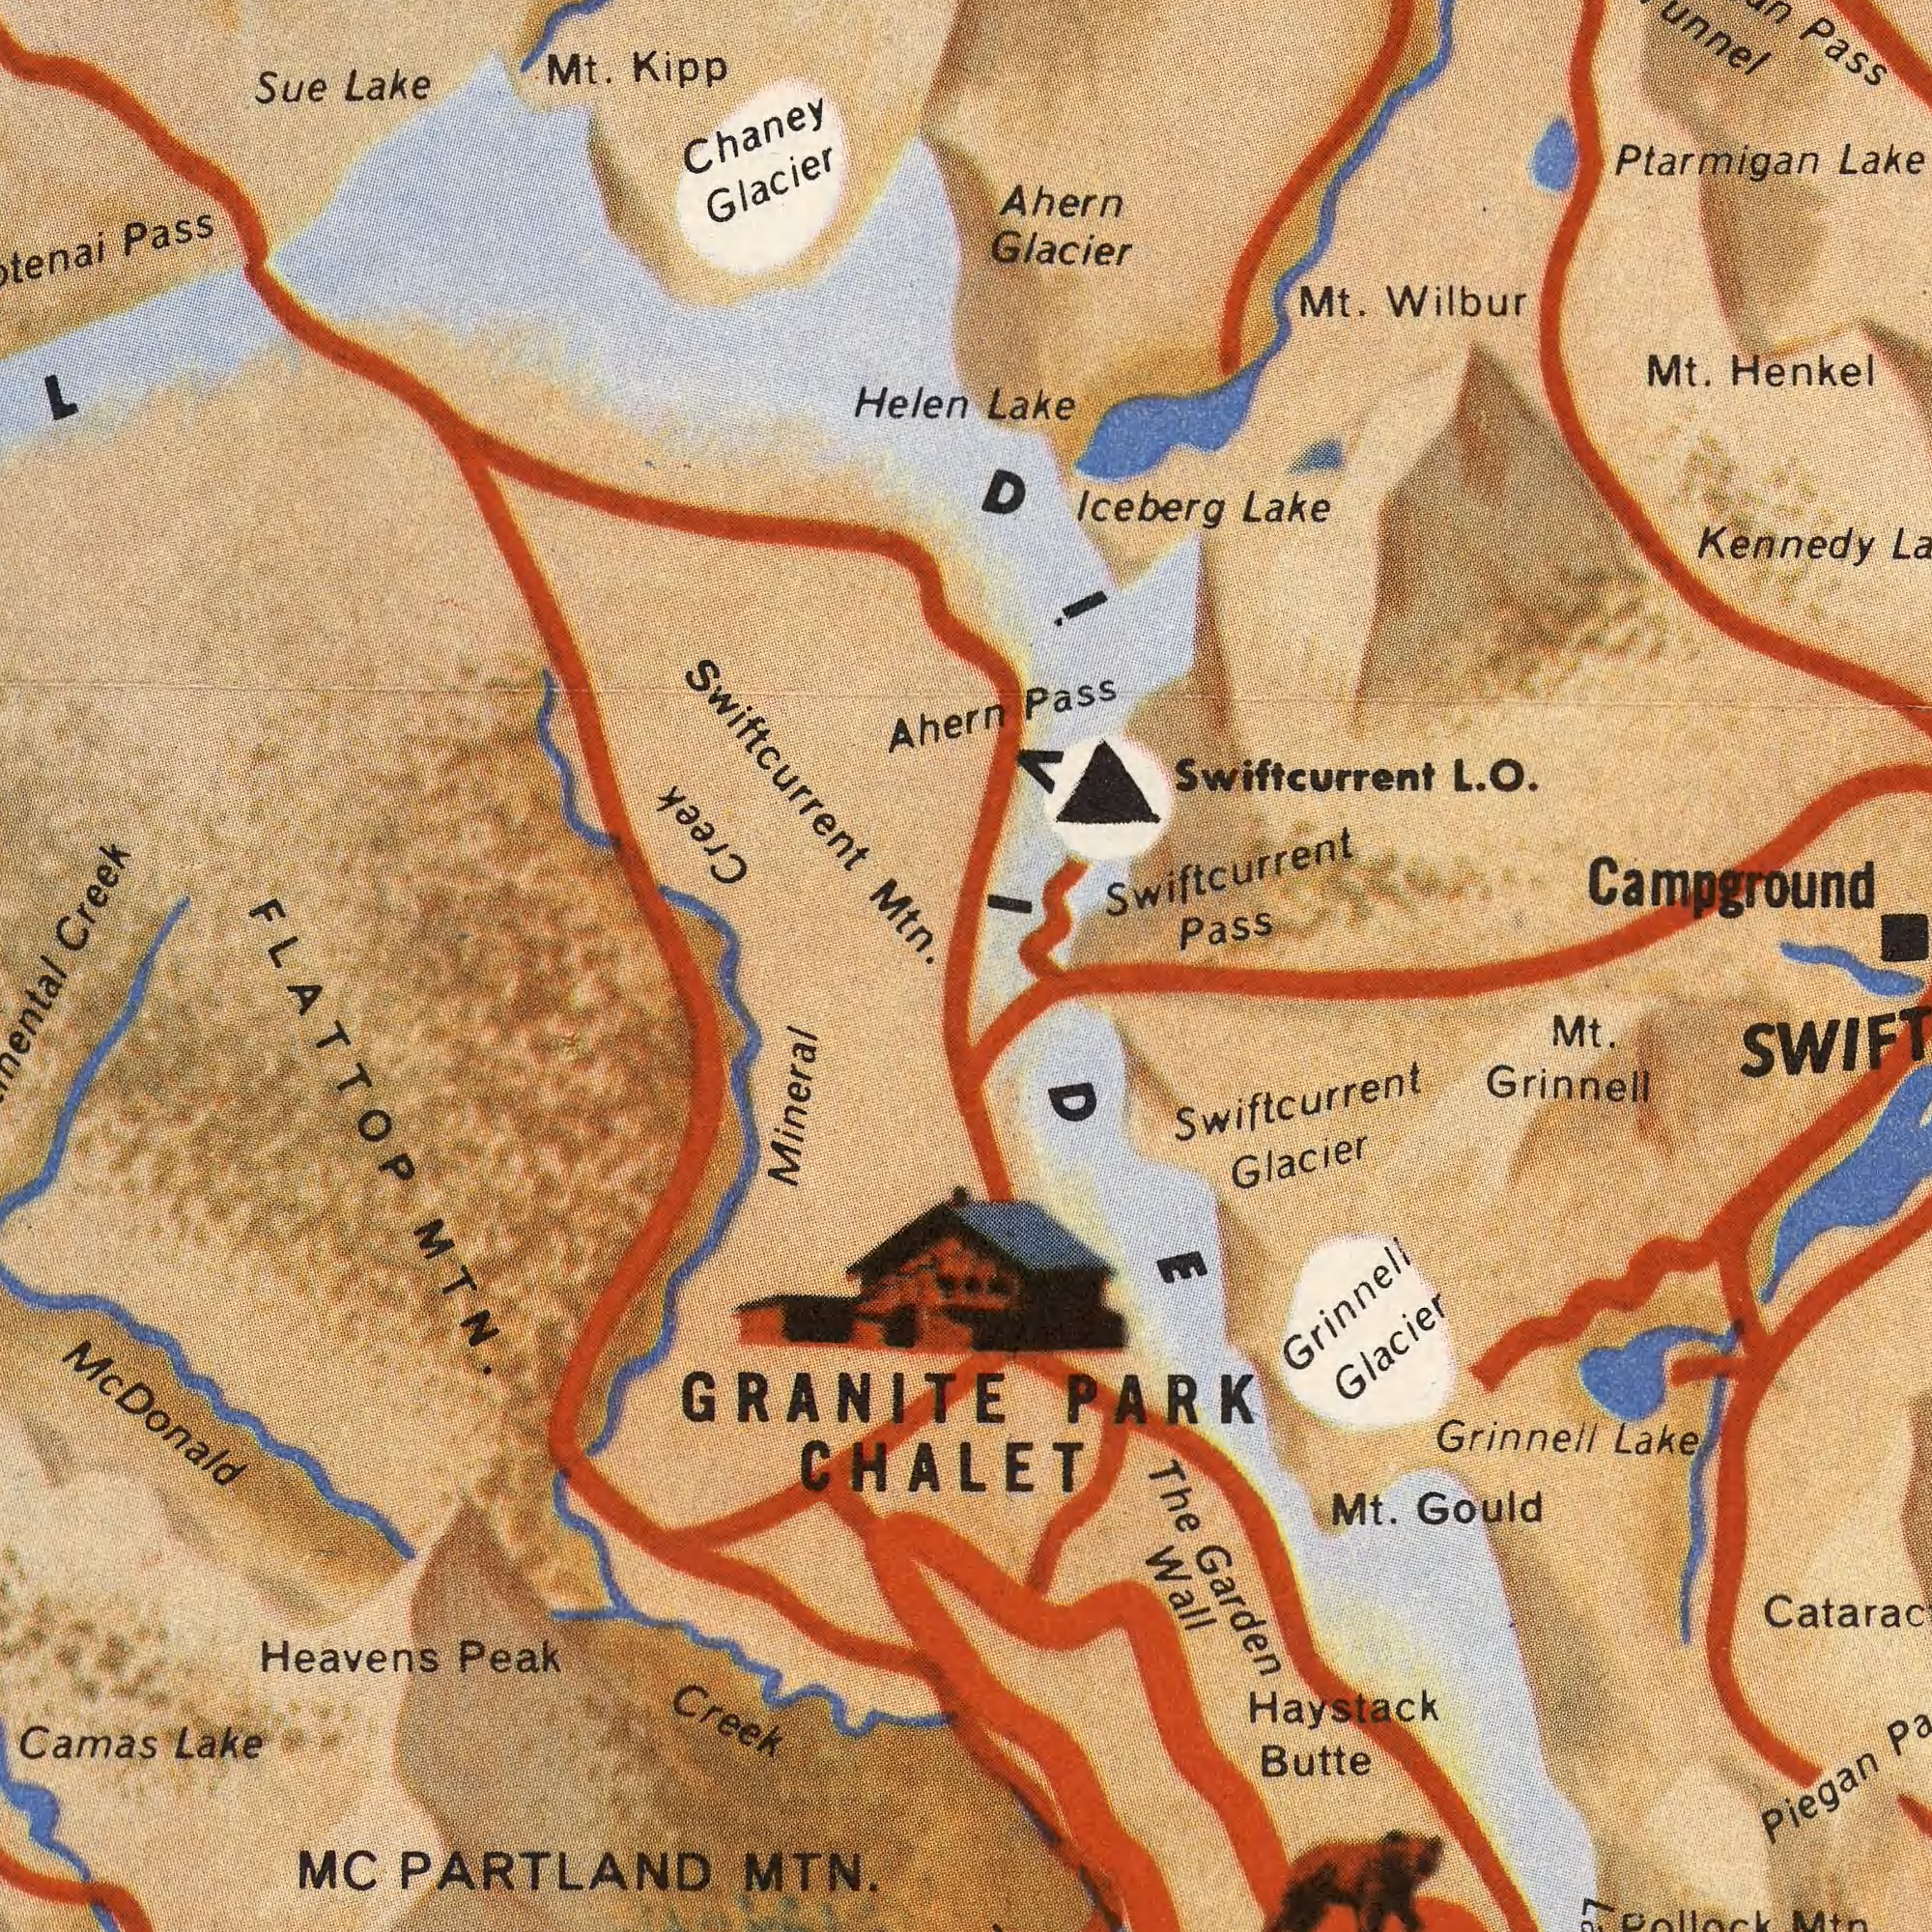What text can you see in the top-left section? Chaney Kipp Creek Lake Helen Mt. Glacier Pass Ahern Swiftcurrent Sue ###L Creek Mtn. What text appears in the bottom-left area of the image? Mc MC Creek Mineral MTN. MTN. PARTLAND Lake GRANITE Peak Heavens Camas FLATTOP CHALET Donald What text is visible in the upper-right corner? Kennedy Ptarmigan Henkel Glacier Wilbur Lake Ahern Pass Campground Mt. Lake Mt. Lake Pass DIVIDE Iceberg Swiftcurrent Pass Swiftcurrent L. O. What text is shown in the bottom-right quadrant? The Haystack Mt. Wall Gould Mt. PARK Grinnell Butte Grinnell Grinnell Lake Piegan Garden Glacier Glacier Swiftcurrent 